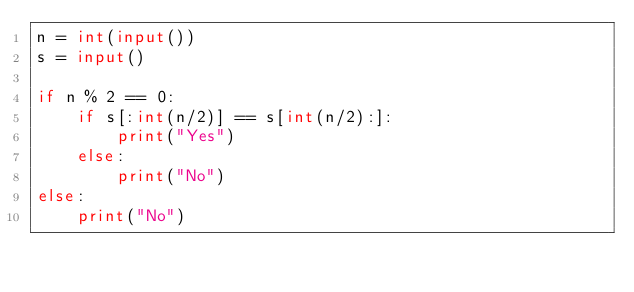<code> <loc_0><loc_0><loc_500><loc_500><_Python_>n = int(input())
s = input()

if n % 2 == 0:
    if s[:int(n/2)] == s[int(n/2):]:
        print("Yes")
    else:
        print("No")
else:
    print("No")</code> 